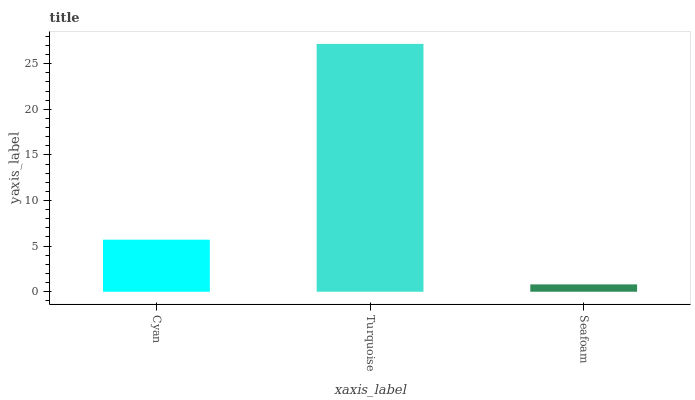Is Turquoise the minimum?
Answer yes or no. No. Is Seafoam the maximum?
Answer yes or no. No. Is Turquoise greater than Seafoam?
Answer yes or no. Yes. Is Seafoam less than Turquoise?
Answer yes or no. Yes. Is Seafoam greater than Turquoise?
Answer yes or no. No. Is Turquoise less than Seafoam?
Answer yes or no. No. Is Cyan the high median?
Answer yes or no. Yes. Is Cyan the low median?
Answer yes or no. Yes. Is Turquoise the high median?
Answer yes or no. No. Is Turquoise the low median?
Answer yes or no. No. 